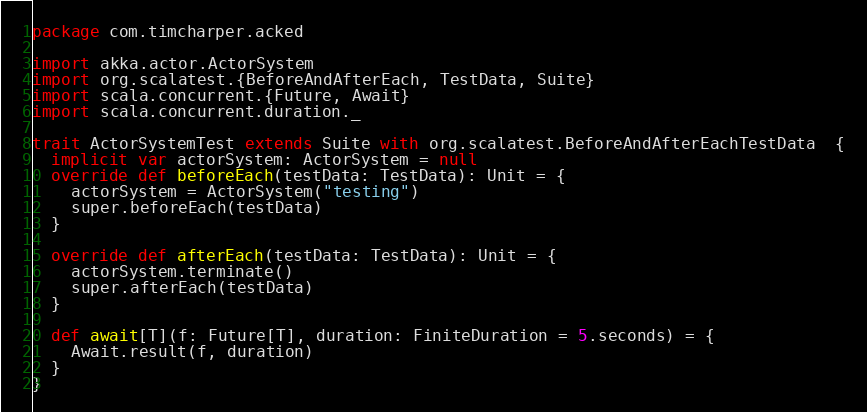Convert code to text. <code><loc_0><loc_0><loc_500><loc_500><_Scala_>package com.timcharper.acked

import akka.actor.ActorSystem
import org.scalatest.{BeforeAndAfterEach, TestData, Suite}
import scala.concurrent.{Future, Await}
import scala.concurrent.duration._

trait ActorSystemTest extends Suite with org.scalatest.BeforeAndAfterEachTestData  {
  implicit var actorSystem: ActorSystem = null
  override def beforeEach(testData: TestData): Unit = {
    actorSystem = ActorSystem("testing")
    super.beforeEach(testData)
  }

  override def afterEach(testData: TestData): Unit = {
    actorSystem.terminate()
    super.afterEach(testData)
  }

  def await[T](f: Future[T], duration: FiniteDuration = 5.seconds) = {
    Await.result(f, duration)
  }
}
</code> 